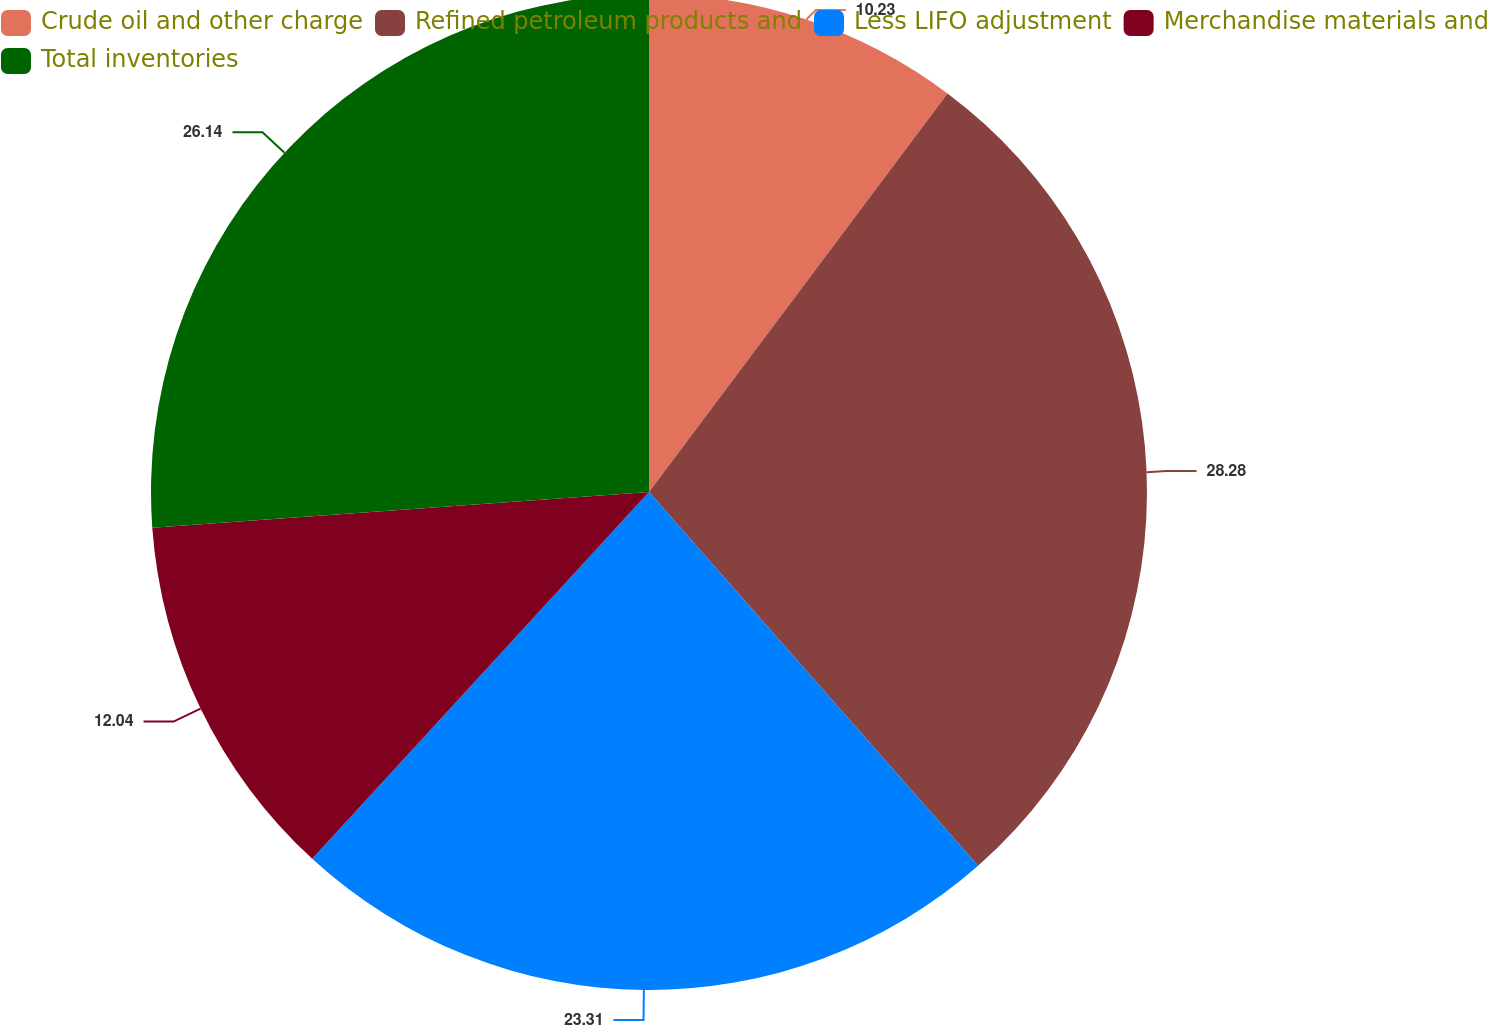Convert chart to OTSL. <chart><loc_0><loc_0><loc_500><loc_500><pie_chart><fcel>Crude oil and other charge<fcel>Refined petroleum products and<fcel>Less LIFO adjustment<fcel>Merchandise materials and<fcel>Total inventories<nl><fcel>10.23%<fcel>28.28%<fcel>23.31%<fcel>12.04%<fcel>26.14%<nl></chart> 